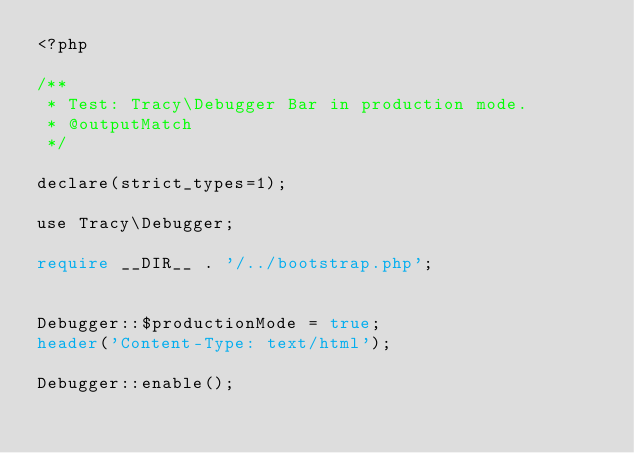Convert code to text. <code><loc_0><loc_0><loc_500><loc_500><_PHP_><?php

/**
 * Test: Tracy\Debugger Bar in production mode.
 * @outputMatch
 */

declare(strict_types=1);

use Tracy\Debugger;

require __DIR__ . '/../bootstrap.php';


Debugger::$productionMode = true;
header('Content-Type: text/html');

Debugger::enable();
</code> 